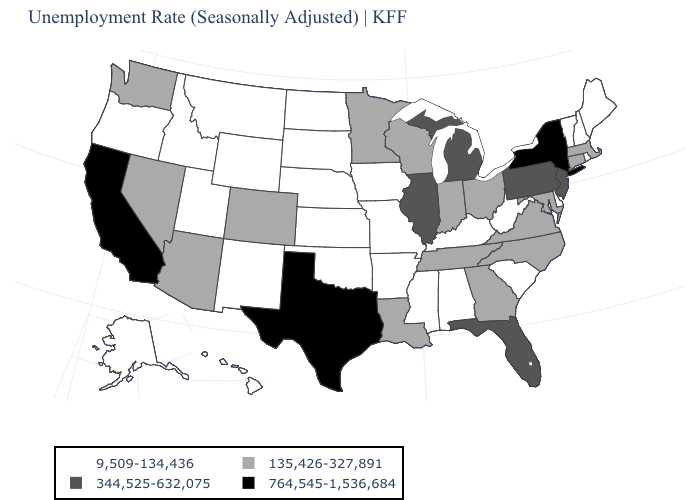Name the states that have a value in the range 135,426-327,891?
Be succinct. Arizona, Colorado, Connecticut, Georgia, Indiana, Louisiana, Maryland, Massachusetts, Minnesota, Nevada, North Carolina, Ohio, Tennessee, Virginia, Washington, Wisconsin. Name the states that have a value in the range 9,509-134,436?
Be succinct. Alabama, Alaska, Arkansas, Delaware, Hawaii, Idaho, Iowa, Kansas, Kentucky, Maine, Mississippi, Missouri, Montana, Nebraska, New Hampshire, New Mexico, North Dakota, Oklahoma, Oregon, Rhode Island, South Carolina, South Dakota, Utah, Vermont, West Virginia, Wyoming. What is the value of Indiana?
Write a very short answer. 135,426-327,891. Name the states that have a value in the range 764,545-1,536,684?
Be succinct. California, New York, Texas. Name the states that have a value in the range 344,525-632,075?
Concise answer only. Florida, Illinois, Michigan, New Jersey, Pennsylvania. What is the highest value in the USA?
Give a very brief answer. 764,545-1,536,684. What is the value of Nevada?
Give a very brief answer. 135,426-327,891. What is the highest value in states that border Maryland?
Be succinct. 344,525-632,075. What is the value of Georgia?
Keep it brief. 135,426-327,891. Does New York have the highest value in the Northeast?
Keep it brief. Yes. Name the states that have a value in the range 344,525-632,075?
Keep it brief. Florida, Illinois, Michigan, New Jersey, Pennsylvania. Does the map have missing data?
Short answer required. No. Name the states that have a value in the range 9,509-134,436?
Keep it brief. Alabama, Alaska, Arkansas, Delaware, Hawaii, Idaho, Iowa, Kansas, Kentucky, Maine, Mississippi, Missouri, Montana, Nebraska, New Hampshire, New Mexico, North Dakota, Oklahoma, Oregon, Rhode Island, South Carolina, South Dakota, Utah, Vermont, West Virginia, Wyoming. What is the value of Massachusetts?
Quick response, please. 135,426-327,891. Among the states that border Missouri , which have the highest value?
Keep it brief. Illinois. 